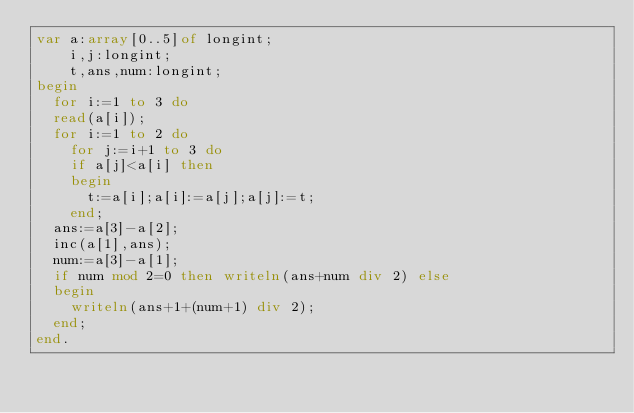<code> <loc_0><loc_0><loc_500><loc_500><_Pascal_>var a:array[0..5]of longint;
    i,j:longint;
    t,ans,num:longint;
begin
  for i:=1 to 3 do
  read(a[i]);
  for i:=1 to 2 do
    for j:=i+1 to 3 do
    if a[j]<a[i] then
    begin
      t:=a[i];a[i]:=a[j];a[j]:=t;
    end;
  ans:=a[3]-a[2];
  inc(a[1],ans);
  num:=a[3]-a[1];
  if num mod 2=0 then writeln(ans+num div 2) else
  begin
    writeln(ans+1+(num+1) div 2);
  end;
end.

</code> 